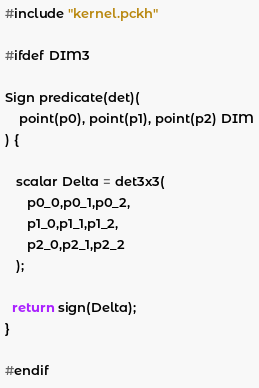Convert code to text. <code><loc_0><loc_0><loc_500><loc_500><_SQL_>#include "kernel.pckh"

#ifdef DIM3

Sign predicate(det)(
    point(p0), point(p1), point(p2) DIM
) {

   scalar Delta = det3x3(
      p0_0,p0_1,p0_2,
      p1_0,p1_1,p1_2,
      p2_0,p2_1,p2_2	    
   );

  return sign(Delta);
}

#endif
</code> 